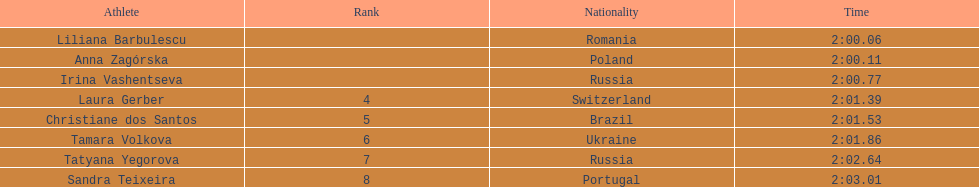Anna zagorska recieved 2nd place, what was her time? 2:00.11. 